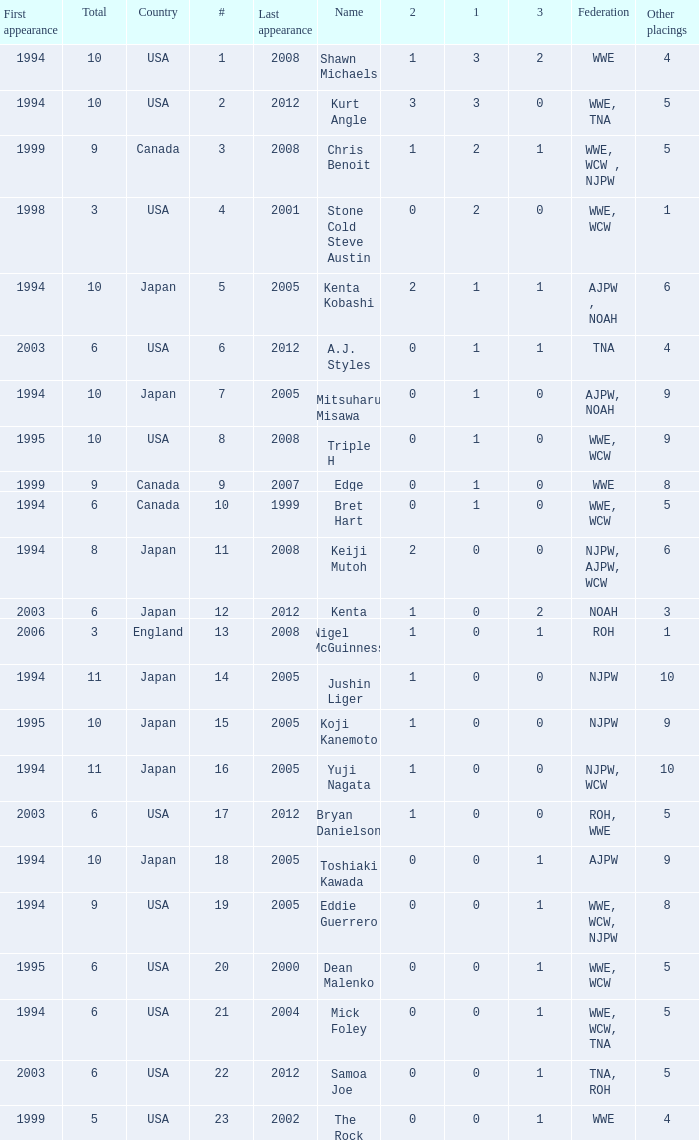How many times has a wrestler from the country of England wrestled in this event? 1.0. 